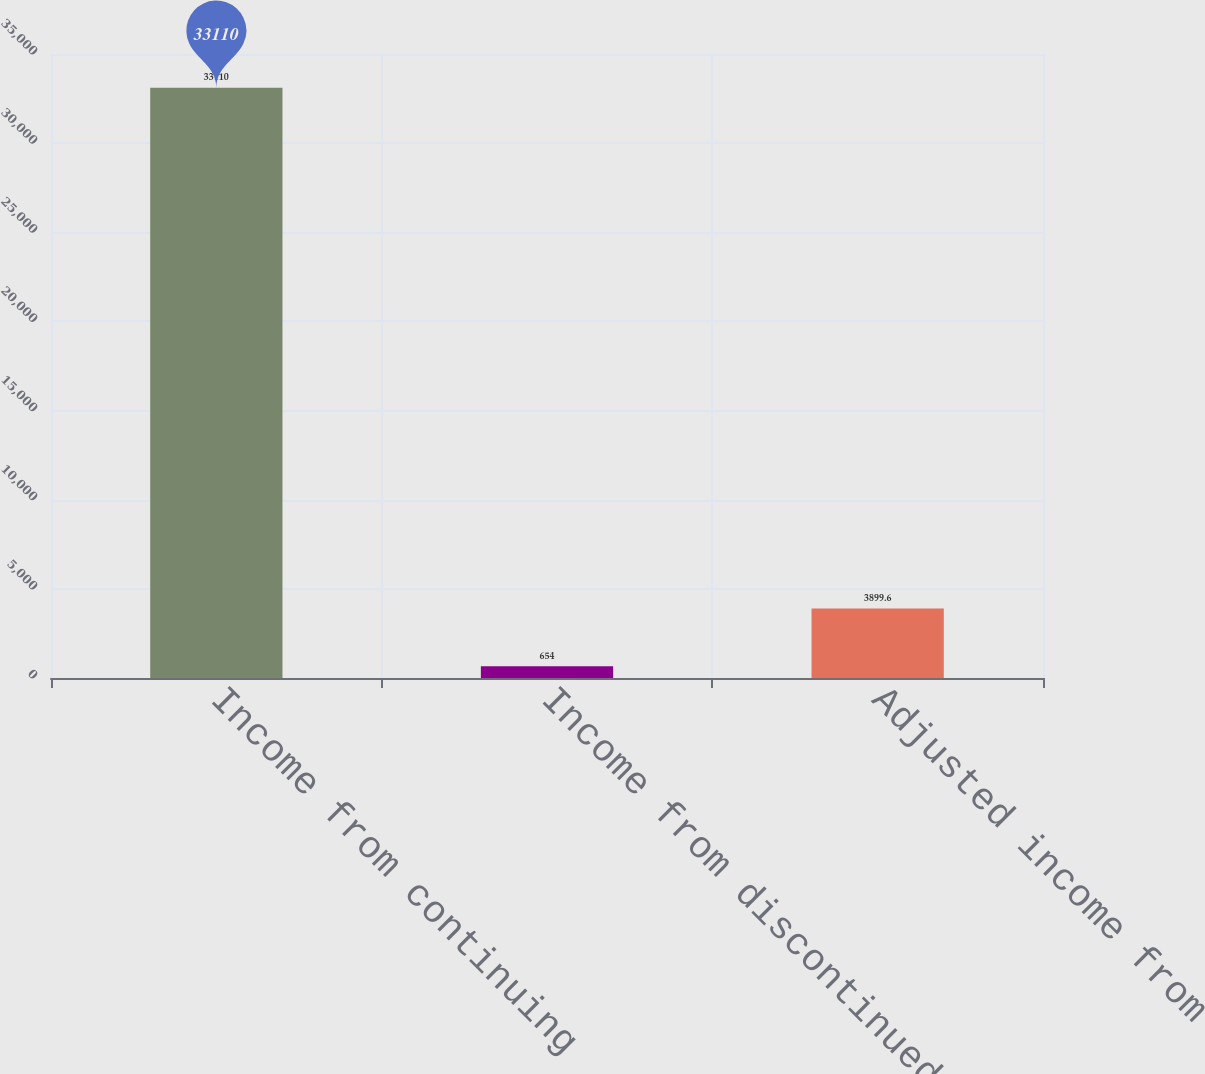Convert chart. <chart><loc_0><loc_0><loc_500><loc_500><bar_chart><fcel>Income from continuing<fcel>Income from discontinued<fcel>Adjusted income from<nl><fcel>33110<fcel>654<fcel>3899.6<nl></chart> 